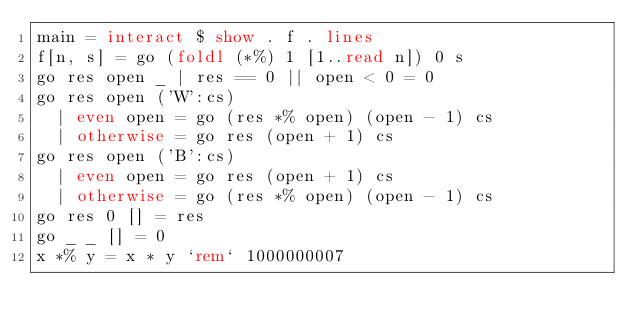Convert code to text. <code><loc_0><loc_0><loc_500><loc_500><_Haskell_>main = interact $ show . f . lines
f[n, s] = go (foldl (*%) 1 [1..read n]) 0 s
go res open _ | res == 0 || open < 0 = 0
go res open ('W':cs)
  | even open = go (res *% open) (open - 1) cs
  | otherwise = go res (open + 1) cs
go res open ('B':cs)
  | even open = go res (open + 1) cs
  | otherwise = go (res *% open) (open - 1) cs
go res 0 [] = res
go _ _ [] = 0
x *% y = x * y `rem` 1000000007</code> 